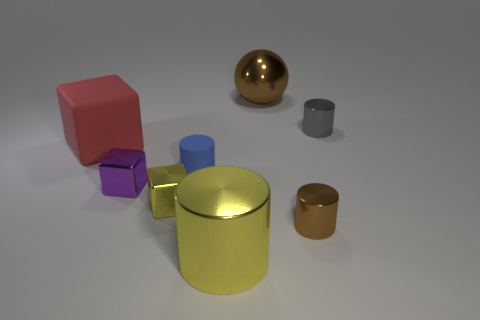Is the material of the brown object that is behind the tiny gray cylinder the same as the tiny object behind the blue matte object?
Provide a succinct answer. Yes. How many brown metal cubes are the same size as the red thing?
Provide a short and direct response. 0. There is a tiny metallic thing that is the same color as the ball; what is its shape?
Provide a short and direct response. Cylinder. There is a tiny thing behind the matte cube; what is it made of?
Offer a terse response. Metal. What number of other tiny shiny things have the same shape as the small yellow thing?
Your response must be concise. 1. What is the shape of the gray object that is made of the same material as the large cylinder?
Your answer should be very brief. Cylinder. What shape is the brown object that is in front of the big shiny thing that is behind the small blue matte cylinder that is in front of the gray metal cylinder?
Provide a short and direct response. Cylinder. Is the number of tiny brown metallic cylinders greater than the number of big purple matte cubes?
Give a very brief answer. Yes. There is a gray thing that is the same shape as the large yellow object; what is its material?
Keep it short and to the point. Metal. Is the material of the small gray cylinder the same as the small yellow object?
Your answer should be very brief. Yes. 